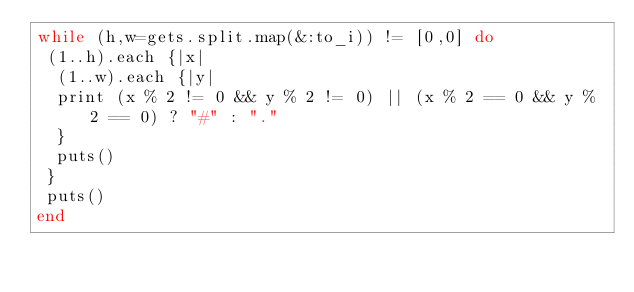<code> <loc_0><loc_0><loc_500><loc_500><_Ruby_>while (h,w=gets.split.map(&:to_i)) != [0,0] do
 (1..h).each {|x| 
  (1..w).each {|y|
  print (x % 2 != 0 && y % 2 != 0) || (x % 2 == 0 && y % 2 == 0) ? "#" : "." 
  }
  puts()
 }
 puts()
end</code> 